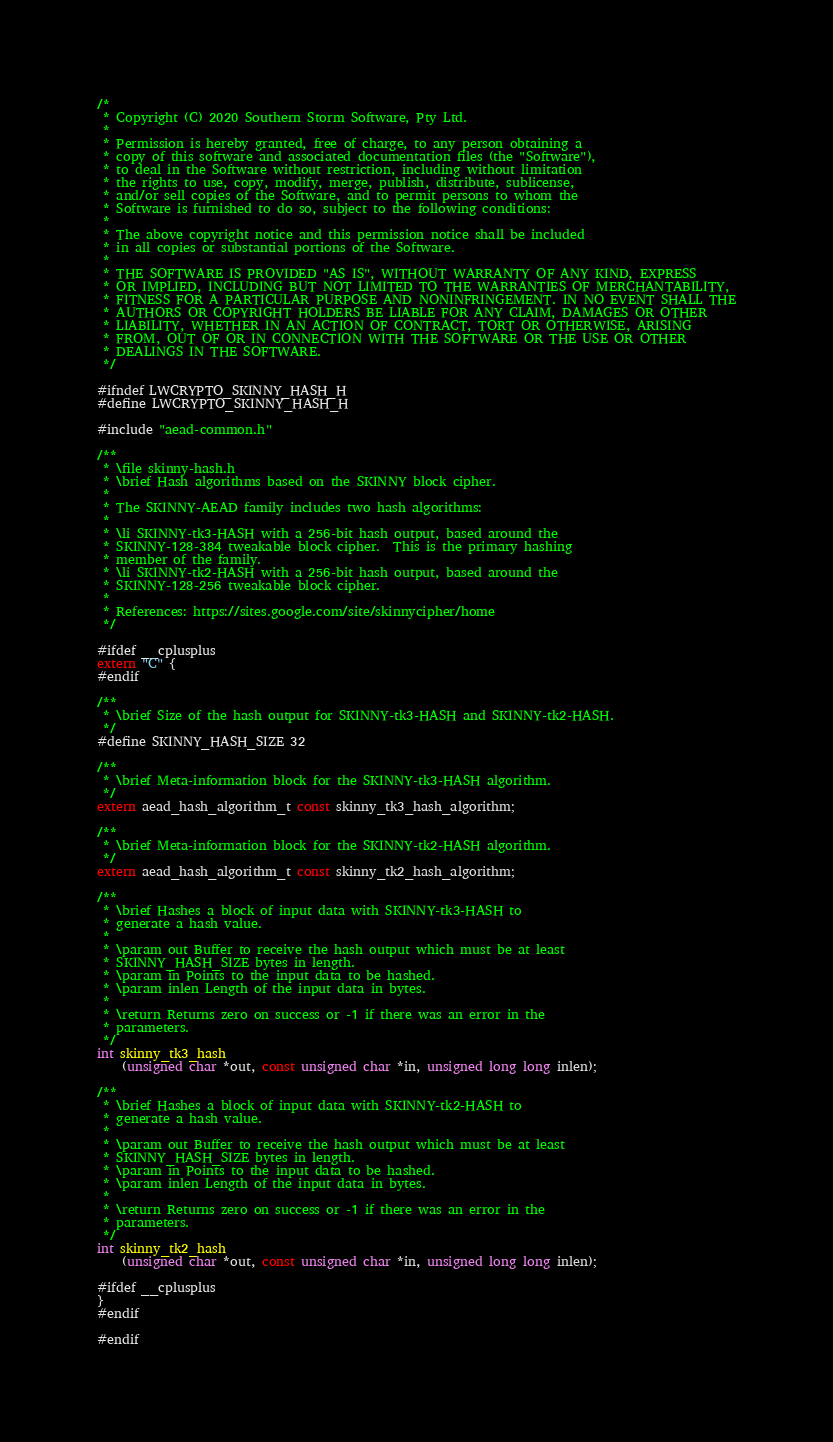Convert code to text. <code><loc_0><loc_0><loc_500><loc_500><_C_>/*
 * Copyright (C) 2020 Southern Storm Software, Pty Ltd.
 *
 * Permission is hereby granted, free of charge, to any person obtaining a
 * copy of this software and associated documentation files (the "Software"),
 * to deal in the Software without restriction, including without limitation
 * the rights to use, copy, modify, merge, publish, distribute, sublicense,
 * and/or sell copies of the Software, and to permit persons to whom the
 * Software is furnished to do so, subject to the following conditions:
 *
 * The above copyright notice and this permission notice shall be included
 * in all copies or substantial portions of the Software.
 *
 * THE SOFTWARE IS PROVIDED "AS IS", WITHOUT WARRANTY OF ANY KIND, EXPRESS
 * OR IMPLIED, INCLUDING BUT NOT LIMITED TO THE WARRANTIES OF MERCHANTABILITY,
 * FITNESS FOR A PARTICULAR PURPOSE AND NONINFRINGEMENT. IN NO EVENT SHALL THE
 * AUTHORS OR COPYRIGHT HOLDERS BE LIABLE FOR ANY CLAIM, DAMAGES OR OTHER
 * LIABILITY, WHETHER IN AN ACTION OF CONTRACT, TORT OR OTHERWISE, ARISING
 * FROM, OUT OF OR IN CONNECTION WITH THE SOFTWARE OR THE USE OR OTHER
 * DEALINGS IN THE SOFTWARE.
 */

#ifndef LWCRYPTO_SKINNY_HASH_H
#define LWCRYPTO_SKINNY_HASH_H

#include "aead-common.h"

/**
 * \file skinny-hash.h
 * \brief Hash algorithms based on the SKINNY block cipher.
 *
 * The SKINNY-AEAD family includes two hash algorithms:
 *
 * \li SKINNY-tk3-HASH with a 256-bit hash output, based around the
 * SKINNY-128-384 tweakable block cipher.  This is the primary hashing
 * member of the family.
 * \li SKINNY-tk2-HASH with a 256-bit hash output, based around the
 * SKINNY-128-256 tweakable block cipher.
 *
 * References: https://sites.google.com/site/skinnycipher/home
 */

#ifdef __cplusplus
extern "C" {
#endif

/**
 * \brief Size of the hash output for SKINNY-tk3-HASH and SKINNY-tk2-HASH.
 */
#define SKINNY_HASH_SIZE 32

/**
 * \brief Meta-information block for the SKINNY-tk3-HASH algorithm.
 */
extern aead_hash_algorithm_t const skinny_tk3_hash_algorithm;

/**
 * \brief Meta-information block for the SKINNY-tk2-HASH algorithm.
 */
extern aead_hash_algorithm_t const skinny_tk2_hash_algorithm;

/**
 * \brief Hashes a block of input data with SKINNY-tk3-HASH to
 * generate a hash value.
 *
 * \param out Buffer to receive the hash output which must be at least
 * SKINNY_HASH_SIZE bytes in length.
 * \param in Points to the input data to be hashed.
 * \param inlen Length of the input data in bytes.
 *
 * \return Returns zero on success or -1 if there was an error in the
 * parameters.
 */
int skinny_tk3_hash
    (unsigned char *out, const unsigned char *in, unsigned long long inlen);

/**
 * \brief Hashes a block of input data with SKINNY-tk2-HASH to
 * generate a hash value.
 *
 * \param out Buffer to receive the hash output which must be at least
 * SKINNY_HASH_SIZE bytes in length.
 * \param in Points to the input data to be hashed.
 * \param inlen Length of the input data in bytes.
 *
 * \return Returns zero on success or -1 if there was an error in the
 * parameters.
 */
int skinny_tk2_hash
    (unsigned char *out, const unsigned char *in, unsigned long long inlen);

#ifdef __cplusplus
}
#endif

#endif
</code> 